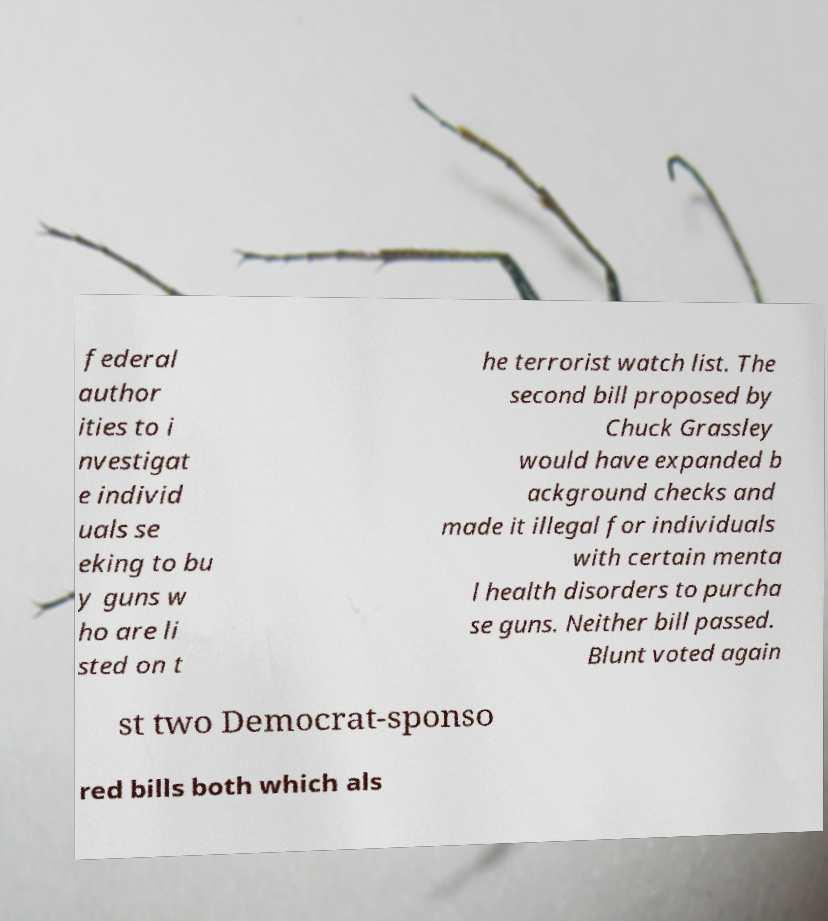Can you accurately transcribe the text from the provided image for me? federal author ities to i nvestigat e individ uals se eking to bu y guns w ho are li sted on t he terrorist watch list. The second bill proposed by Chuck Grassley would have expanded b ackground checks and made it illegal for individuals with certain menta l health disorders to purcha se guns. Neither bill passed. Blunt voted again st two Democrat-sponso red bills both which als 